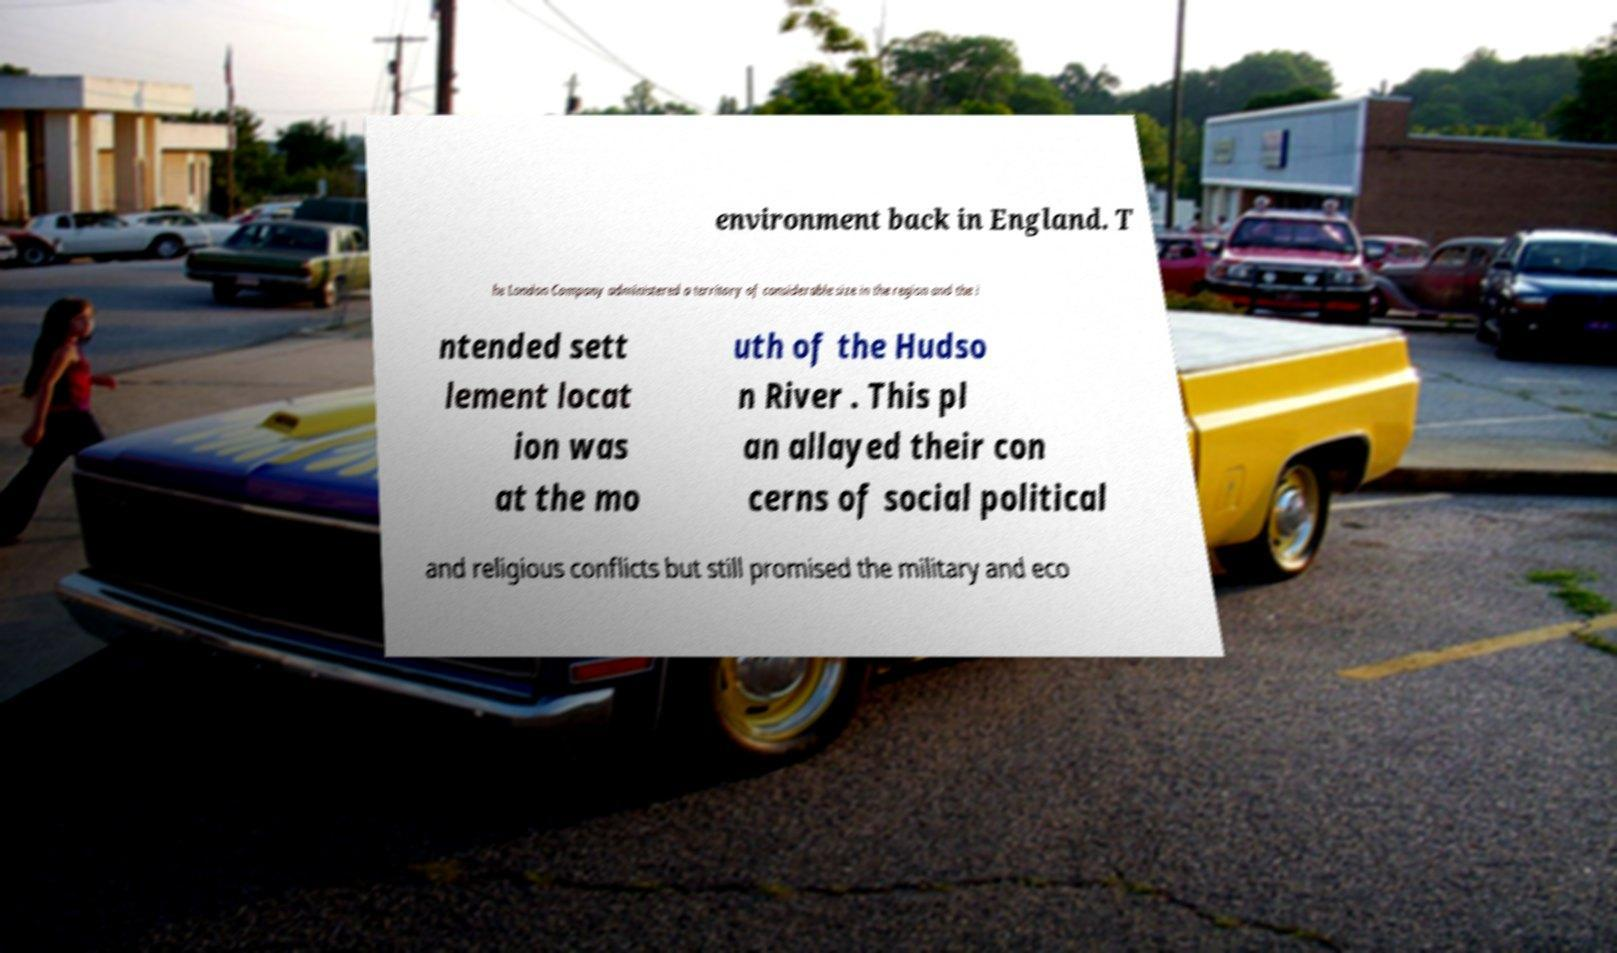Please read and relay the text visible in this image. What does it say? environment back in England. T he London Company administered a territory of considerable size in the region and the i ntended sett lement locat ion was at the mo uth of the Hudso n River . This pl an allayed their con cerns of social political and religious conflicts but still promised the military and eco 